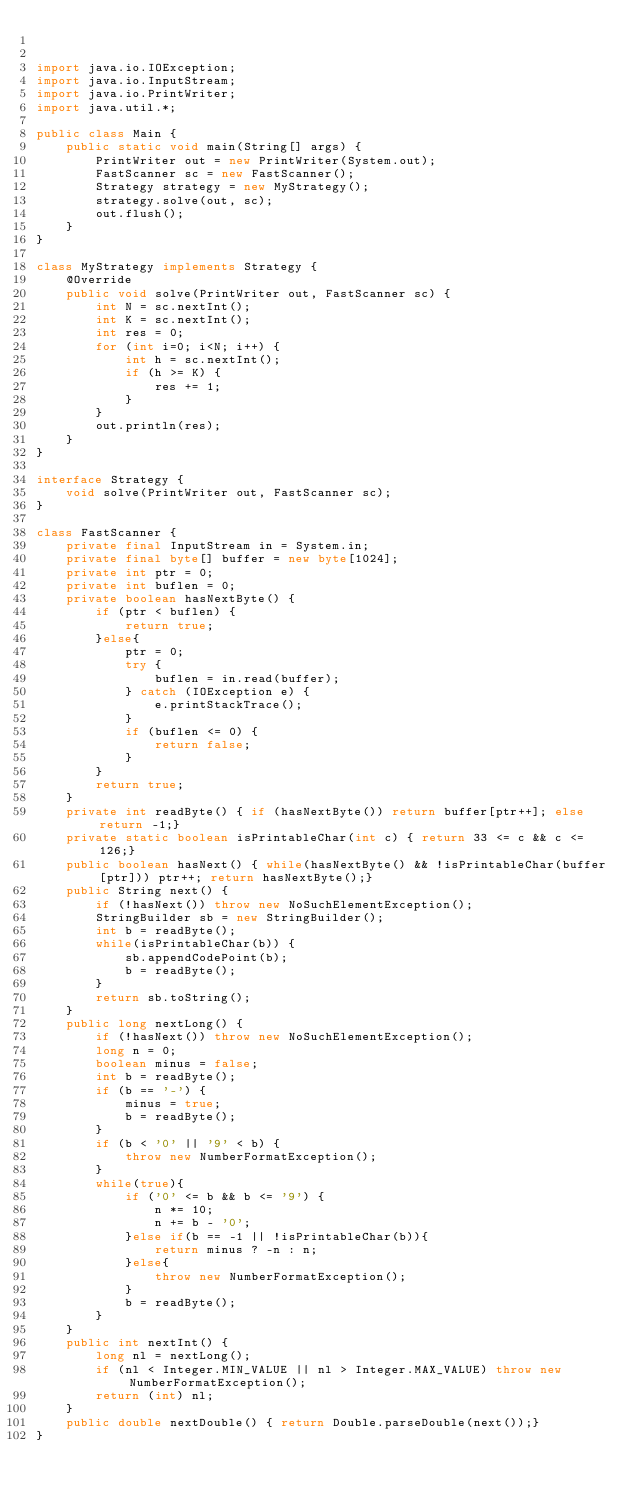<code> <loc_0><loc_0><loc_500><loc_500><_Java_>

import java.io.IOException;
import java.io.InputStream;
import java.io.PrintWriter;
import java.util.*;

public class Main {
    public static void main(String[] args) {
        PrintWriter out = new PrintWriter(System.out);
        FastScanner sc = new FastScanner();
        Strategy strategy = new MyStrategy();
        strategy.solve(out, sc);
        out.flush();
    }
}

class MyStrategy implements Strategy {
    @Override
    public void solve(PrintWriter out, FastScanner sc) {
        int N = sc.nextInt();
        int K = sc.nextInt();
        int res = 0;
        for (int i=0; i<N; i++) {
            int h = sc.nextInt();
            if (h >= K) {
                res += 1;
            }
        }
        out.println(res);
    }
}

interface Strategy {
    void solve(PrintWriter out, FastScanner sc);
}

class FastScanner {
    private final InputStream in = System.in;
    private final byte[] buffer = new byte[1024];
    private int ptr = 0;
    private int buflen = 0;
    private boolean hasNextByte() {
        if (ptr < buflen) {
            return true;
        }else{
            ptr = 0;
            try {
                buflen = in.read(buffer);
            } catch (IOException e) {
                e.printStackTrace();
            }
            if (buflen <= 0) {
                return false;
            }
        }
        return true;
    }
    private int readByte() { if (hasNextByte()) return buffer[ptr++]; else return -1;}
    private static boolean isPrintableChar(int c) { return 33 <= c && c <= 126;}
    public boolean hasNext() { while(hasNextByte() && !isPrintableChar(buffer[ptr])) ptr++; return hasNextByte();}
    public String next() {
        if (!hasNext()) throw new NoSuchElementException();
        StringBuilder sb = new StringBuilder();
        int b = readByte();
        while(isPrintableChar(b)) {
            sb.appendCodePoint(b);
            b = readByte();
        }
        return sb.toString();
    }
    public long nextLong() {
        if (!hasNext()) throw new NoSuchElementException();
        long n = 0;
        boolean minus = false;
        int b = readByte();
        if (b == '-') {
            minus = true;
            b = readByte();
        }
        if (b < '0' || '9' < b) {
            throw new NumberFormatException();
        }
        while(true){
            if ('0' <= b && b <= '9') {
                n *= 10;
                n += b - '0';
            }else if(b == -1 || !isPrintableChar(b)){
                return minus ? -n : n;
            }else{
                throw new NumberFormatException();
            }
            b = readByte();
        }
    }
    public int nextInt() {
        long nl = nextLong();
        if (nl < Integer.MIN_VALUE || nl > Integer.MAX_VALUE) throw new NumberFormatException();
        return (int) nl;
    }
    public double nextDouble() { return Double.parseDouble(next());}
}
</code> 